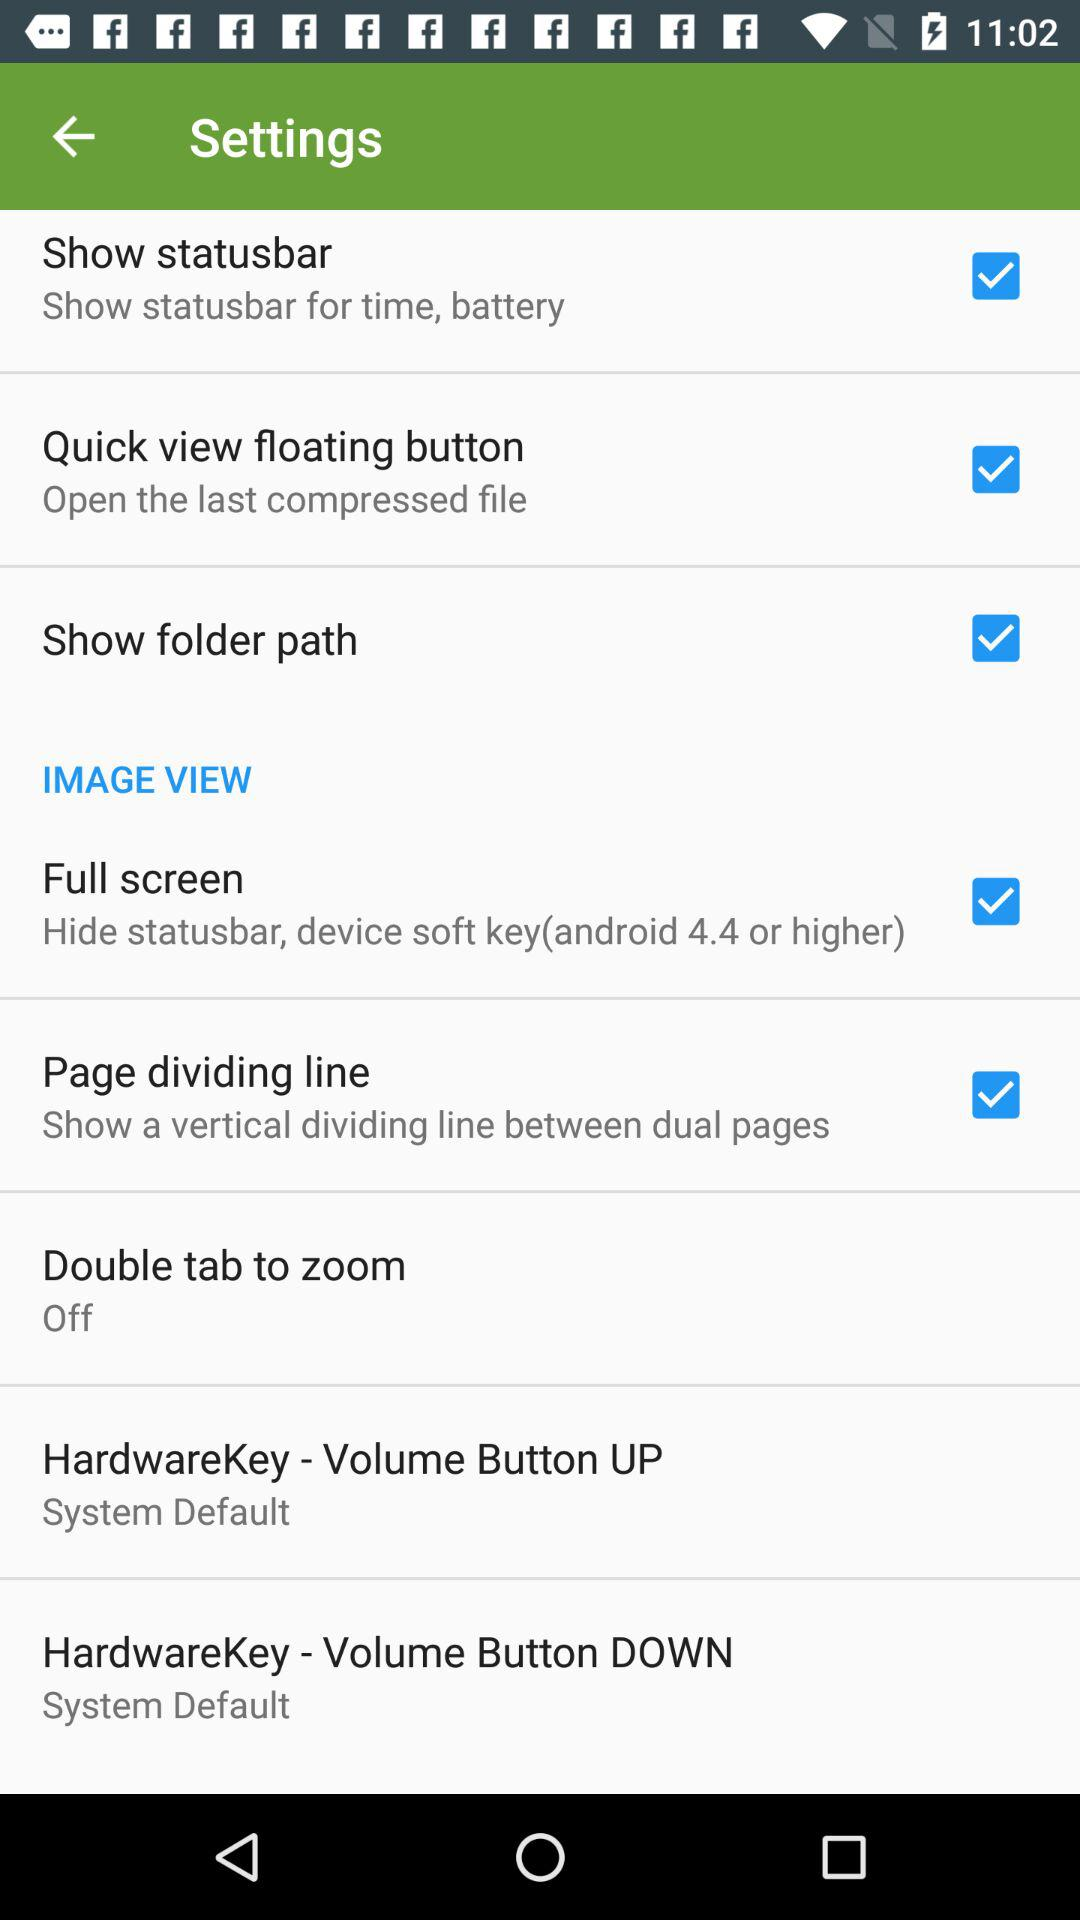What is the status of the "Show folder path"? The status is "on". 